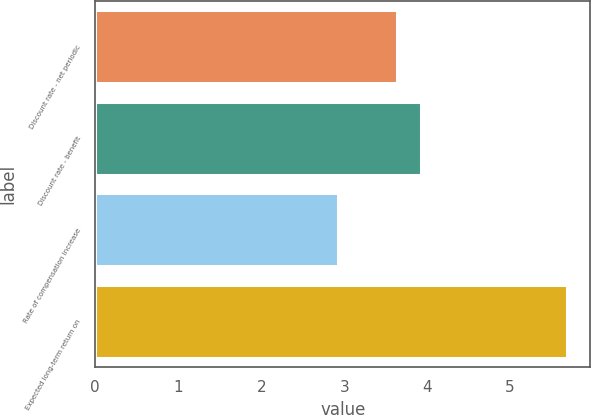<chart> <loc_0><loc_0><loc_500><loc_500><bar_chart><fcel>Discount rate - net periodic<fcel>Discount rate - benefit<fcel>Rate of compensation increase<fcel>Expected long-term return on<nl><fcel>3.64<fcel>3.92<fcel>2.92<fcel>5.68<nl></chart> 